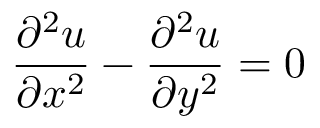Convert formula to latex. <formula><loc_0><loc_0><loc_500><loc_500>{ \frac { \partial ^ { 2 } u } { \partial x ^ { 2 } } } - { \frac { \partial ^ { 2 } u } { \partial y ^ { 2 } } } = 0</formula> 